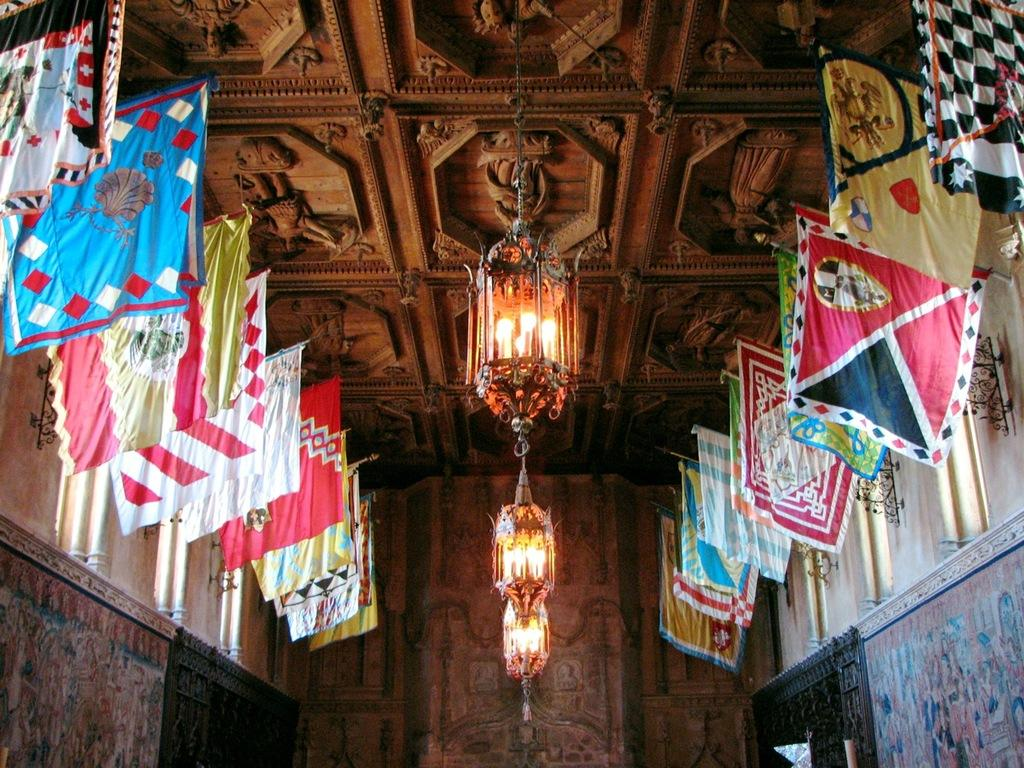What type of space is depicted in the image? The image shows a view of a ceiling hall. What decorative elements can be seen in the hall? There are colorful flags on both sides of the hall. What is the main light source in the hall? There is a hanging lantern in the middle of the ceiling. Where is the faucet located in the image? There is no faucet present in the image. What type of dinner is being served in the hall? The image does not show any dinner or food being served; it only depicts the ceiling hall with flags and a hanging lantern. 